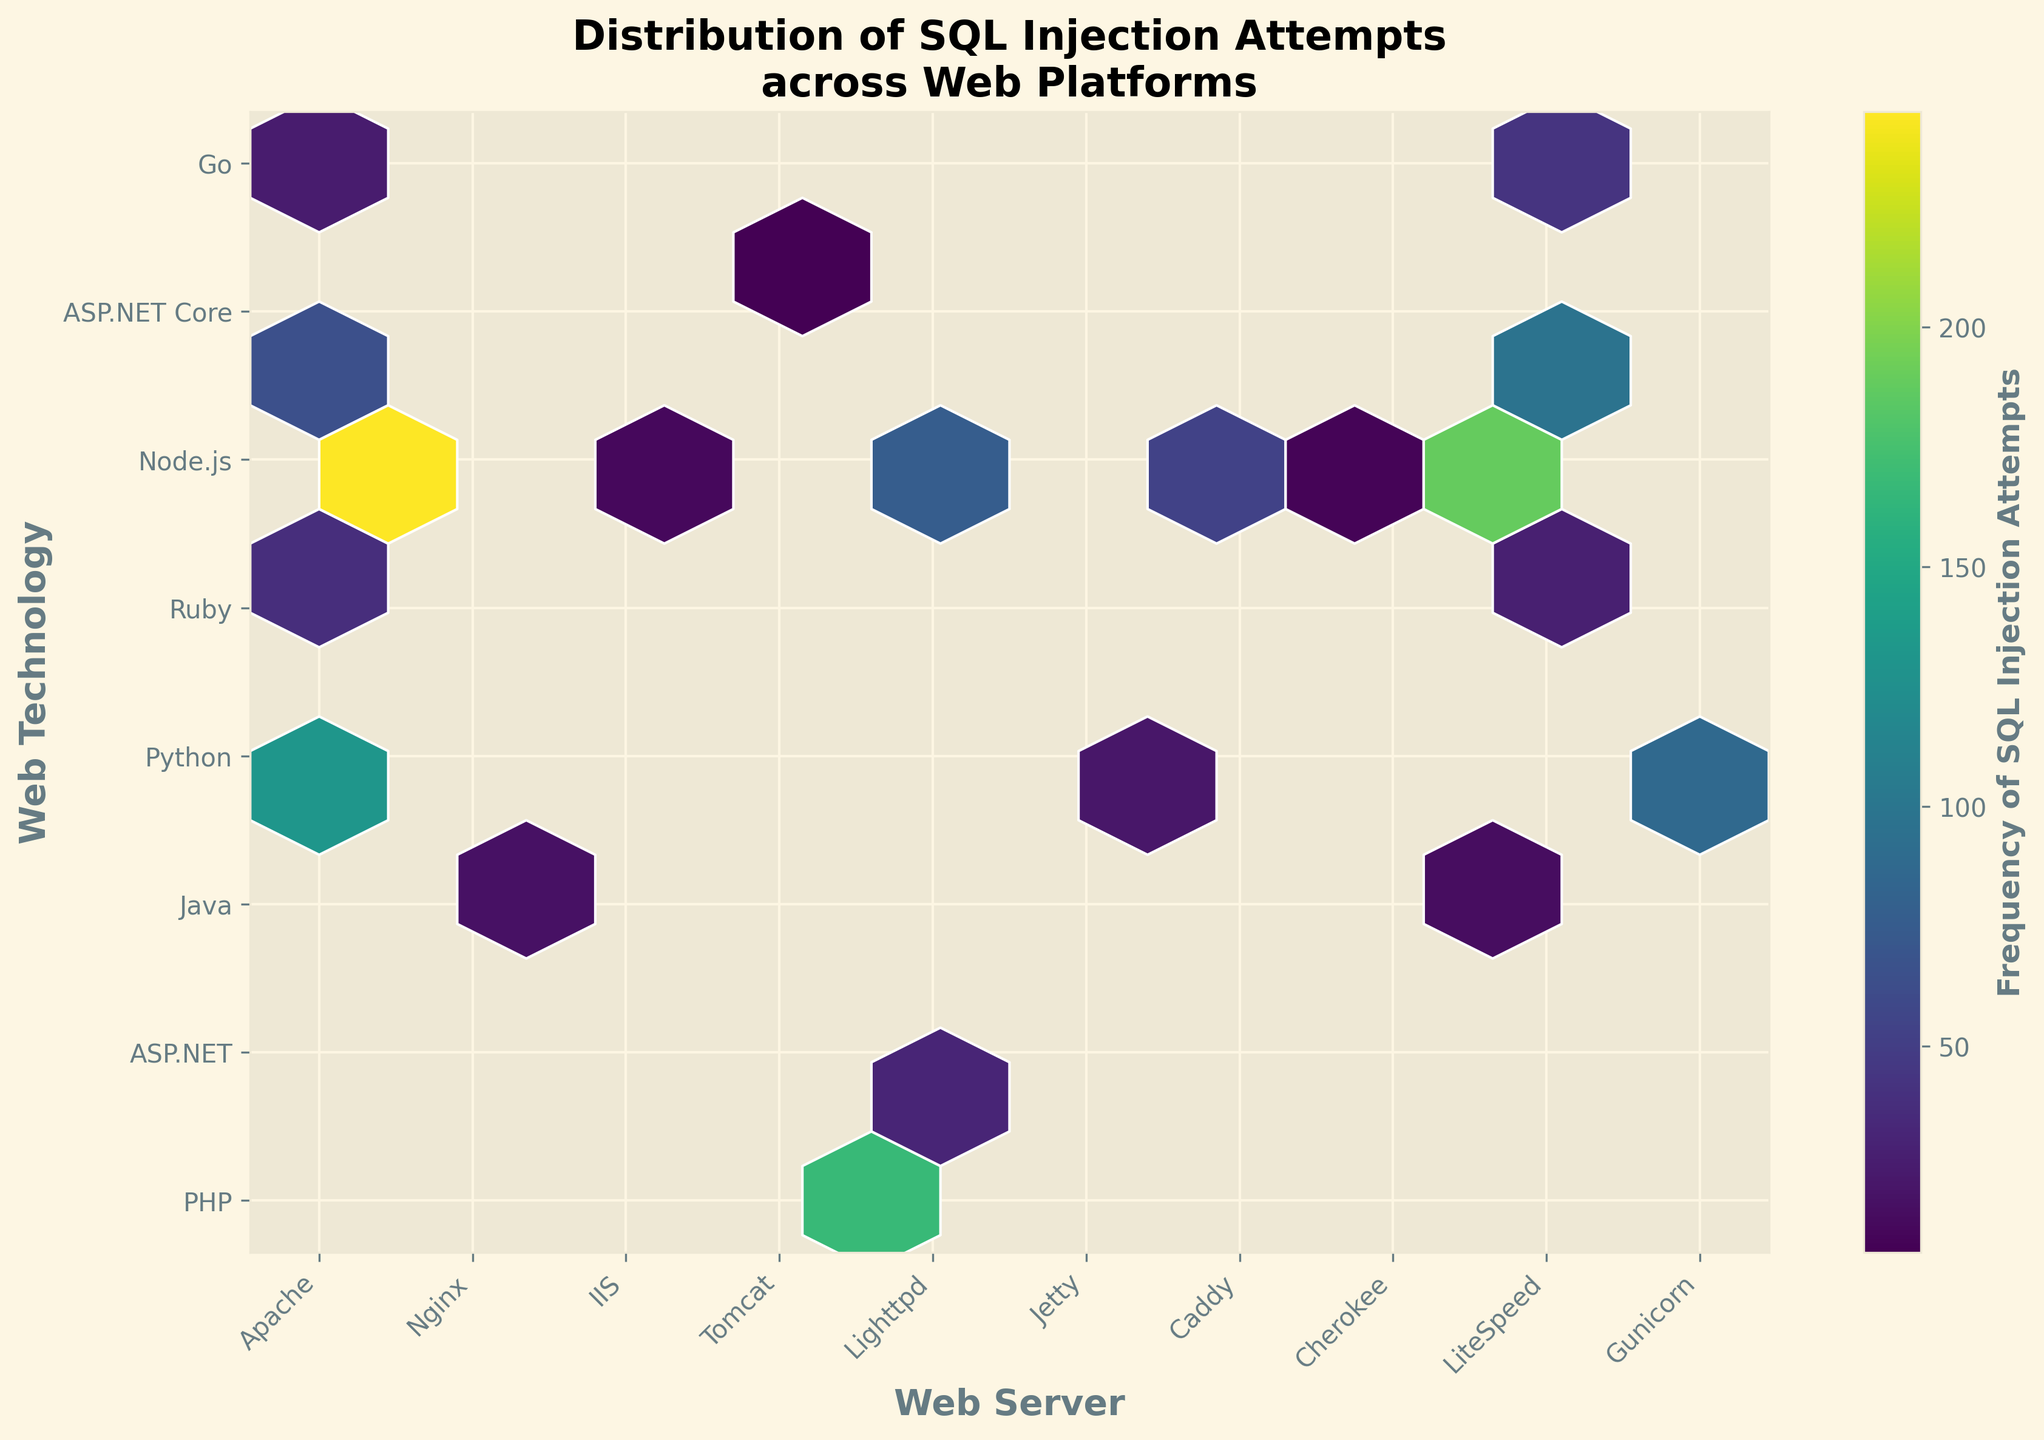How many unique web servers are represented in the plot? Examine the x-axis labels to identify the unique web servers.
Answer: 10 Which web server exhibits the highest frequency of SQL injection attempts? Look for the densest hexbin on the plot and check the corresponding x-axis label.
Answer: Apache Is there a web technology that appears across multiple web servers? Look at the y-axis labels to see if any web technology appears in more than one hexbin.
Answer: PHP What is the range of frequencies for the attempts across all platforms? The color bar indicates the range of frequencies used in the plot.
Answer: 7 to 245 Among Apache and Nginx, which server has more variety in web technologies targeted by SQL injection attempts? Compare the number of different web technology labels (y-axis) associated with Apache and Nginx.
Answer: Apache Which combination of web server and technology has the lowest frequency of SQL injection attempts? Identify the hexbin with the lightest color and check the corresponding x and y-axis labels.
Answer: Gunicorn, Python How does the frequency of SQL injection attempts on IIS/ASP.NET compare to IIS/PHP? Find the corresponding hexagons and compare their color intensities.
Answer: IIS/ASP.NET attempts are higher Which hexbin has the closest frequency to 100 SQL injection attempts? Use the color mapping and the color bar to identify the hexagon around the frequency of 100.
Answer: Nginx, Python 